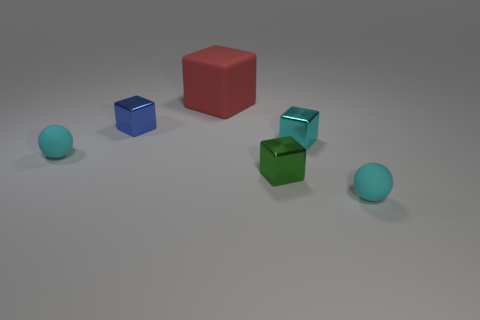Does the small ball that is to the left of the blue metal cube have the same material as the big red block?
Keep it short and to the point. Yes. What material is the cyan sphere that is left of the red block?
Make the answer very short. Rubber. There is a cyan matte sphere in front of the tiny thing left of the blue thing; what size is it?
Give a very brief answer. Small. Are there any blocks that have the same material as the large object?
Your response must be concise. No. The big red rubber thing on the left side of the small green metal thing that is in front of the small cyan object that is on the left side of the small cyan metal cube is what shape?
Give a very brief answer. Cube. There is a small shiny object behind the tiny cyan cube; is its color the same as the tiny sphere to the left of the big red cube?
Your answer should be compact. No. Is there anything else that has the same size as the blue object?
Keep it short and to the point. Yes. There is a blue shiny cube; are there any rubber spheres on the right side of it?
Your response must be concise. Yes. How many green things are the same shape as the small blue thing?
Keep it short and to the point. 1. What color is the small ball that is to the left of the ball that is in front of the small cyan matte ball to the left of the rubber cube?
Your answer should be very brief. Cyan. 